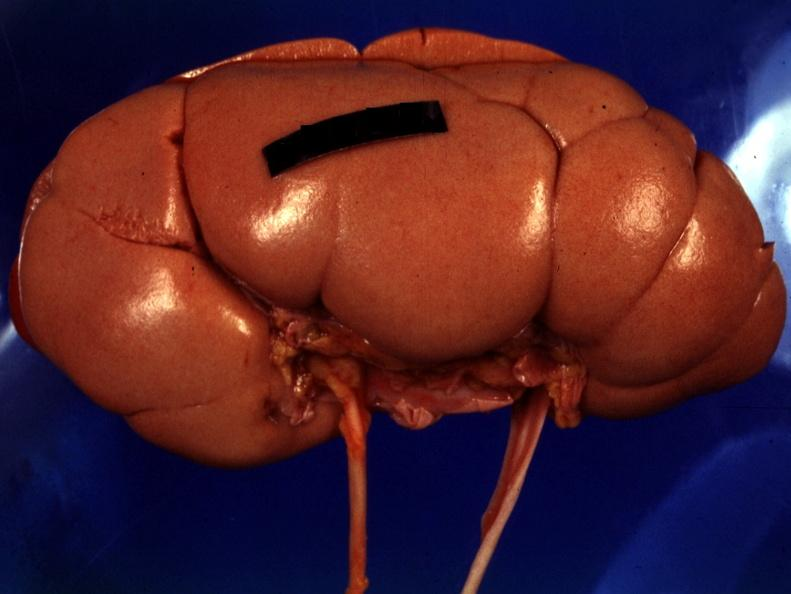does ameloblastoma show good photo except for reflected lights?
Answer the question using a single word or phrase. No 